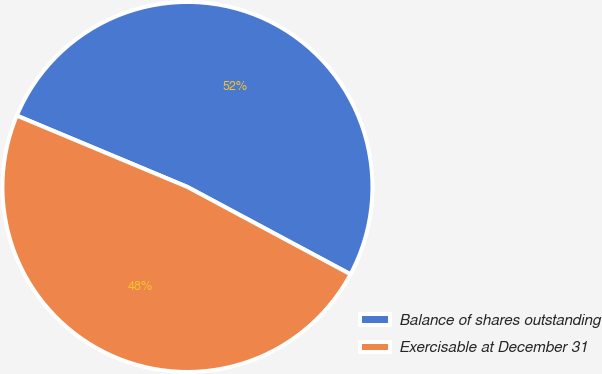<chart> <loc_0><loc_0><loc_500><loc_500><pie_chart><fcel>Balance of shares outstanding<fcel>Exercisable at December 31<nl><fcel>51.52%<fcel>48.48%<nl></chart> 